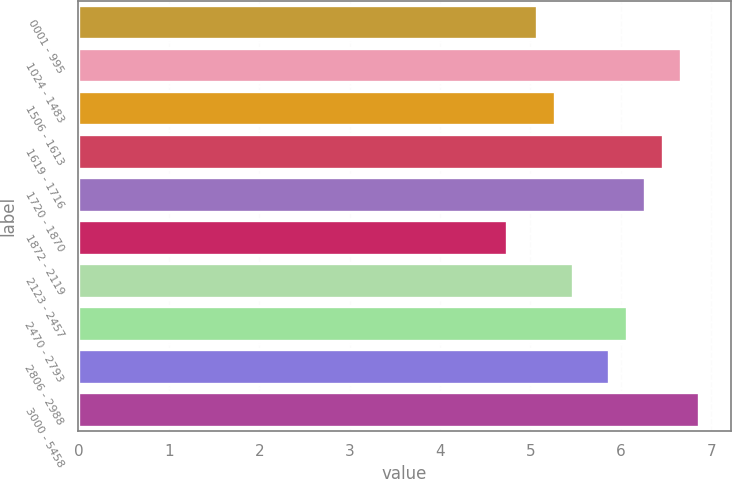Convert chart to OTSL. <chart><loc_0><loc_0><loc_500><loc_500><bar_chart><fcel>0001 - 995<fcel>1024 - 1483<fcel>1506 - 1613<fcel>1619 - 1716<fcel>1720 - 1870<fcel>1872 - 2119<fcel>2123 - 2457<fcel>2470 - 2793<fcel>2806 - 2988<fcel>3000 - 5458<nl><fcel>5.07<fcel>6.67<fcel>5.27<fcel>6.47<fcel>6.27<fcel>4.74<fcel>5.47<fcel>6.07<fcel>5.87<fcel>6.87<nl></chart> 